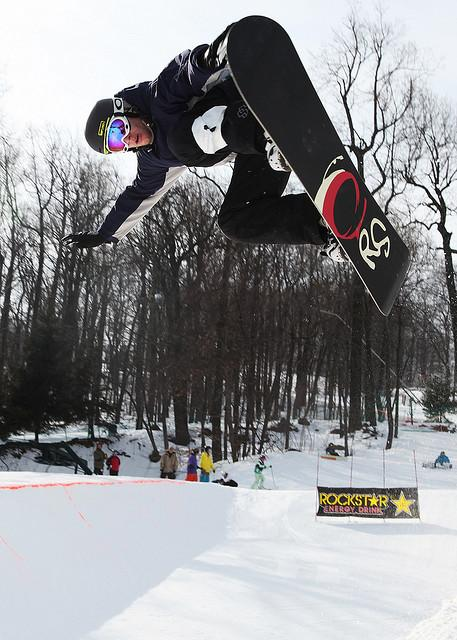How many flavors available in Rock star energy drink?

Choices:
A) ten
B) 15
C) 20
D) 25 20 